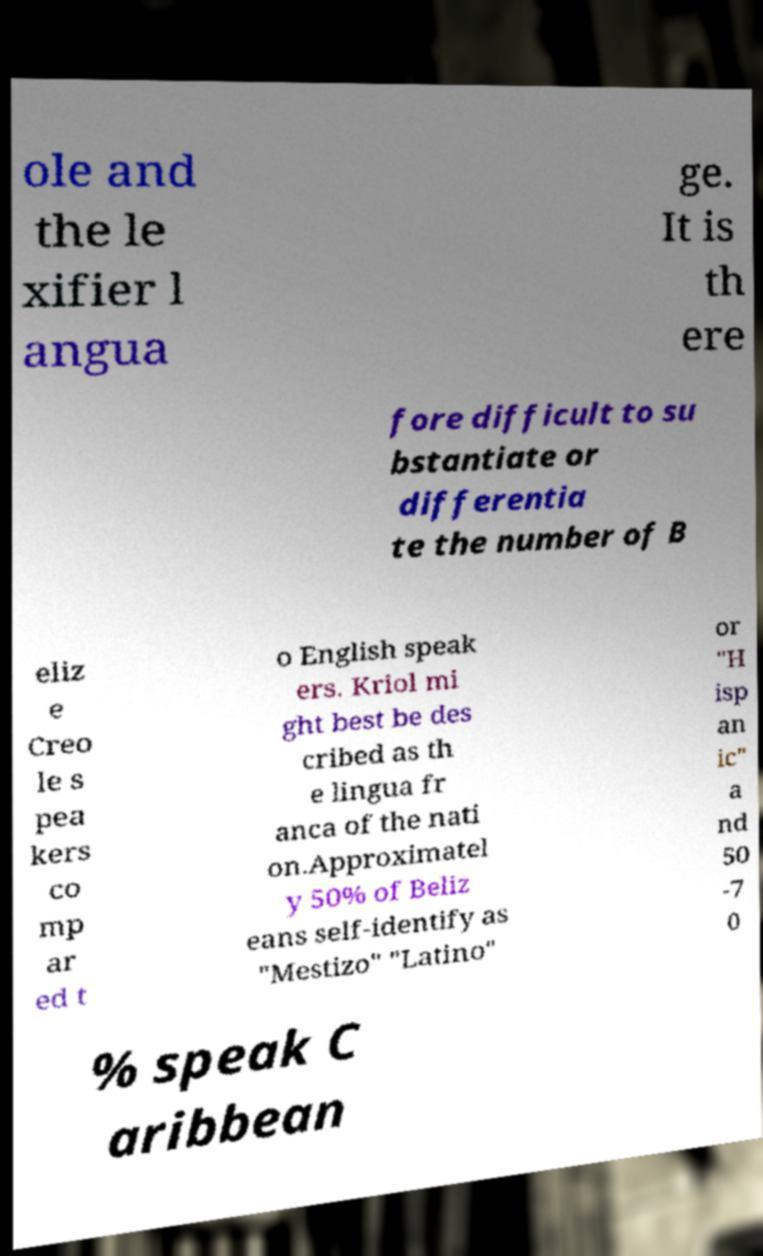For documentation purposes, I need the text within this image transcribed. Could you provide that? ole and the le xifier l angua ge. It is th ere fore difficult to su bstantiate or differentia te the number of B eliz e Creo le s pea kers co mp ar ed t o English speak ers. Kriol mi ght best be des cribed as th e lingua fr anca of the nati on.Approximatel y 50% of Beliz eans self-identify as "Mestizo" "Latino" or "H isp an ic" a nd 50 -7 0 % speak C aribbean 